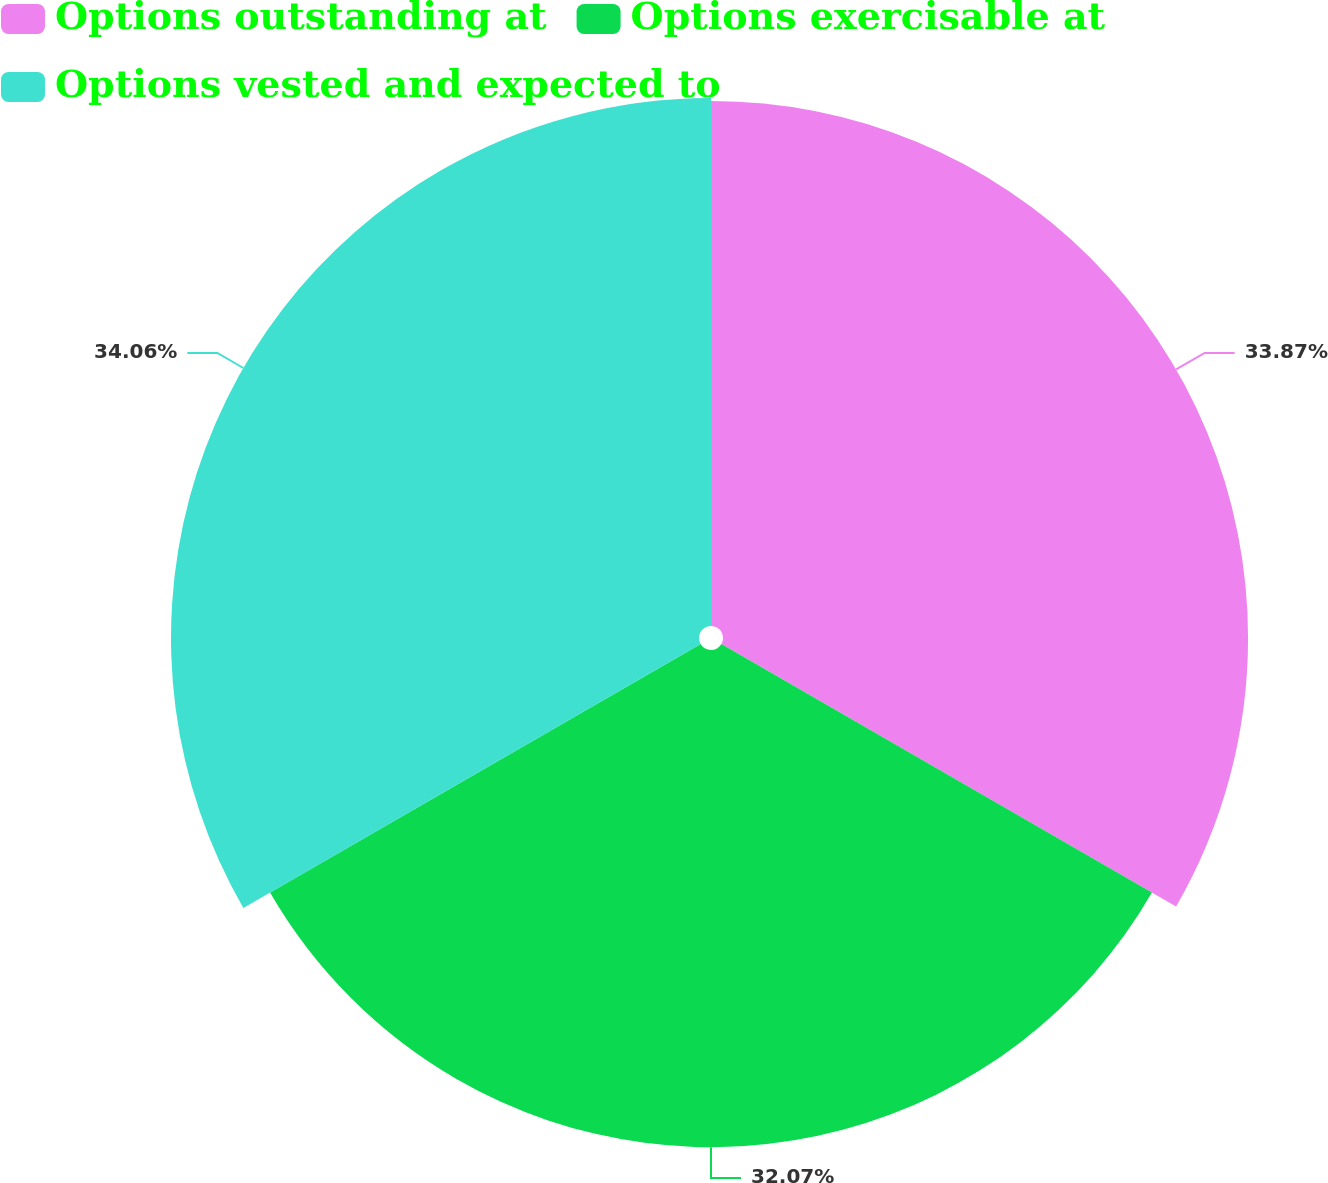<chart> <loc_0><loc_0><loc_500><loc_500><pie_chart><fcel>Options outstanding at<fcel>Options exercisable at<fcel>Options vested and expected to<nl><fcel>33.87%<fcel>32.07%<fcel>34.06%<nl></chart> 